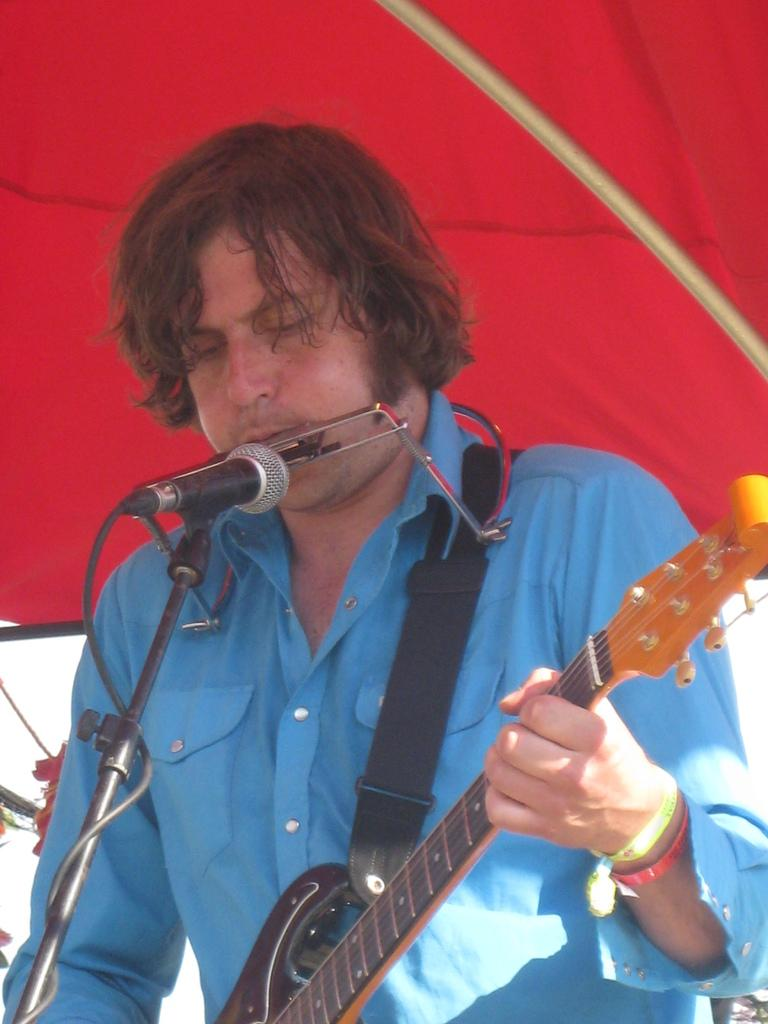What is the main subject of the image? The main subject of the image is a man. What is the man wearing in the image? The man is wearing a blue shirt. What is the man doing in the image? The man is singing and playing a guitar. What tool is the man using to amplify his voice? The man is using a microphone. What type of sand can be seen in the image? There is no sand present in the image. How many houses are visible in the image? There are no houses visible in the image. 